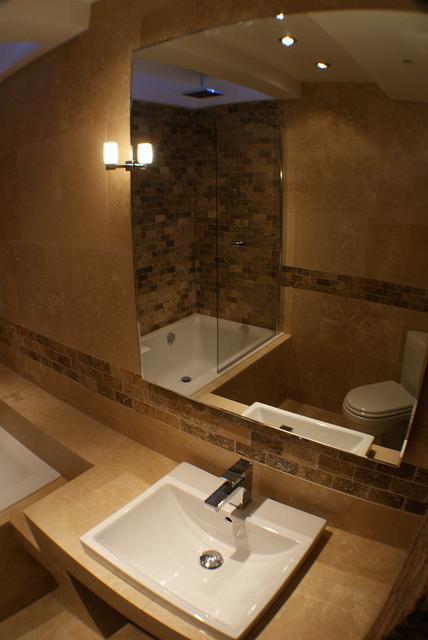How many sinks can you see?
Give a very brief answer. 2. How many men are resting their head on their hand?
Give a very brief answer. 0. 